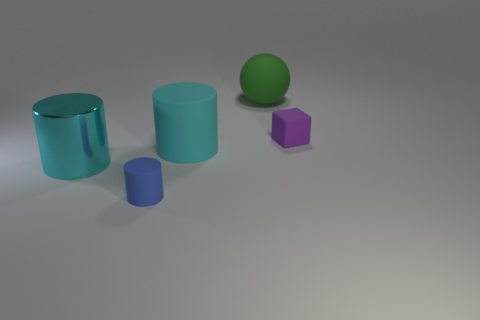Are there any other things that are the same shape as the big green object?
Make the answer very short. No. There is a rubber object that is to the right of the green matte ball; what size is it?
Provide a short and direct response. Small. Do the cylinder that is behind the big cyan shiny object and the large cylinder to the left of the large cyan rubber thing have the same color?
Your answer should be compact. Yes. There is a tiny thing in front of the cyan cylinder that is to the right of the small thing to the left of the big sphere; what is its material?
Ensure brevity in your answer.  Rubber. Is there a rubber cube of the same size as the shiny cylinder?
Your response must be concise. No. There is a blue thing that is the same size as the block; what is its material?
Offer a terse response. Rubber. There is a tiny thing that is behind the big matte cylinder; what shape is it?
Ensure brevity in your answer.  Cube. Is the material of the large cyan cylinder to the left of the tiny blue object the same as the cyan cylinder on the right side of the big cyan shiny cylinder?
Provide a succinct answer. No. What number of blue matte objects are the same shape as the purple matte thing?
Offer a very short reply. 0. There is another large cylinder that is the same color as the shiny cylinder; what material is it?
Your response must be concise. Rubber. 